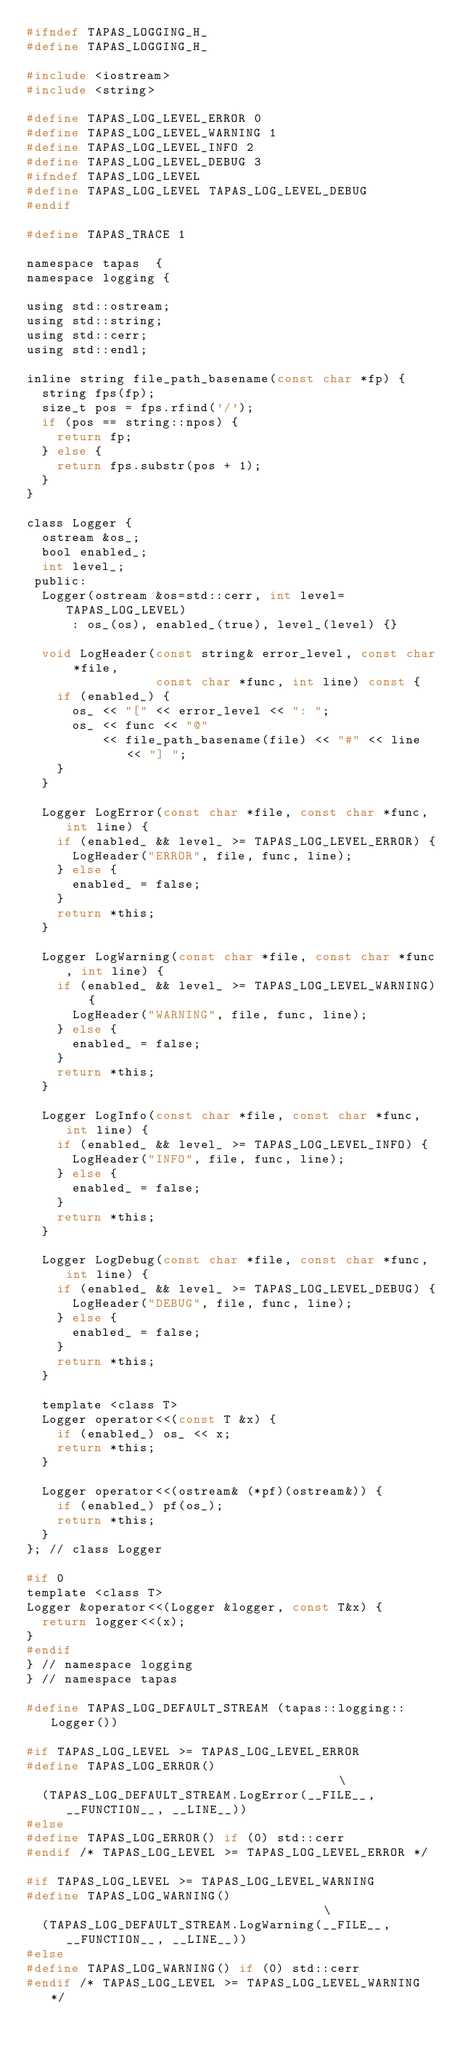Convert code to text. <code><loc_0><loc_0><loc_500><loc_500><_C_>#ifndef TAPAS_LOGGING_H_
#define TAPAS_LOGGING_H_

#include <iostream>
#include <string>

#define TAPAS_LOG_LEVEL_ERROR 0
#define TAPAS_LOG_LEVEL_WARNING 1
#define TAPAS_LOG_LEVEL_INFO 2
#define TAPAS_LOG_LEVEL_DEBUG 3
#ifndef TAPAS_LOG_LEVEL
#define TAPAS_LOG_LEVEL TAPAS_LOG_LEVEL_DEBUG
#endif

#define TAPAS_TRACE 1

namespace tapas  {
namespace logging {

using std::ostream;
using std::string;
using std::cerr;
using std::endl;

inline string file_path_basename(const char *fp) {
  string fps(fp);
  size_t pos = fps.rfind('/');
  if (pos == string::npos) {
    return fp;
  } else {
    return fps.substr(pos + 1);
  }
}
    
class Logger {
  ostream &os_;
  bool enabled_;
  int level_;
 public:	
  Logger(ostream &os=std::cerr, int level=TAPAS_LOG_LEVEL)
      : os_(os), enabled_(true), level_(level) {}

  void LogHeader(const string& error_level, const char *file,
                 const char *func, int line) const {
    if (enabled_) {
      os_ << "[" << error_level << ": ";
      os_ << func << "@"
          << file_path_basename(file) << "#" << line << "] ";
    }
  }

  Logger LogError(const char *file, const char *func, int line) {
    if (enabled_ && level_ >= TAPAS_LOG_LEVEL_ERROR) {
      LogHeader("ERROR", file, func, line);
    } else {
      enabled_ = false;
    }
    return *this;    
  }

  Logger LogWarning(const char *file, const char *func, int line) {
    if (enabled_ && level_ >= TAPAS_LOG_LEVEL_WARNING) {
      LogHeader("WARNING", file, func, line);
    } else {
      enabled_ = false;
    }
    return *this;
  }

  Logger LogInfo(const char *file, const char *func, int line) {
    if (enabled_ && level_ >= TAPAS_LOG_LEVEL_INFO) {
      LogHeader("INFO", file, func, line);
    } else {
      enabled_ = false;
    }
    return *this;
  }

  Logger LogDebug(const char *file, const char *func, int line) {
    if (enabled_ && level_ >= TAPAS_LOG_LEVEL_DEBUG) {
      LogHeader("DEBUG", file, func, line);
    } else {
      enabled_ = false;
    }
    return *this;
  }

  template <class T>
  Logger operator<<(const T &x) {
    if (enabled_) os_ << x;
    return *this;
  }

  Logger operator<<(ostream& (*pf)(ostream&)) {
    if (enabled_) pf(os_);
    return *this;
  }
}; // class Logger

#if 0
template <class T>
Logger &operator<<(Logger &logger, const T&x) {
  return logger<<(x);
}
#endif
} // namespace logging
} // namespace tapas

#define TAPAS_LOG_DEFAULT_STREAM (tapas::logging::Logger())

#if TAPAS_LOG_LEVEL >= TAPAS_LOG_LEVEL_ERROR
#define TAPAS_LOG_ERROR()                                       \
  (TAPAS_LOG_DEFAULT_STREAM.LogError(__FILE__, __FUNCTION__, __LINE__))
#else
#define TAPAS_LOG_ERROR() if (0) std::cerr 
#endif /* TAPAS_LOG_LEVEL >= TAPAS_LOG_LEVEL_ERROR */

#if TAPAS_LOG_LEVEL >= TAPAS_LOG_LEVEL_WARNING
#define TAPAS_LOG_WARNING()                                     \
  (TAPAS_LOG_DEFAULT_STREAM.LogWarning(__FILE__, __FUNCTION__, __LINE__))  
#else
#define TAPAS_LOG_WARNING() if (0) std::cerr 
#endif /* TAPAS_LOG_LEVEL >= TAPAS_LOG_LEVEL_WARNING */
</code> 